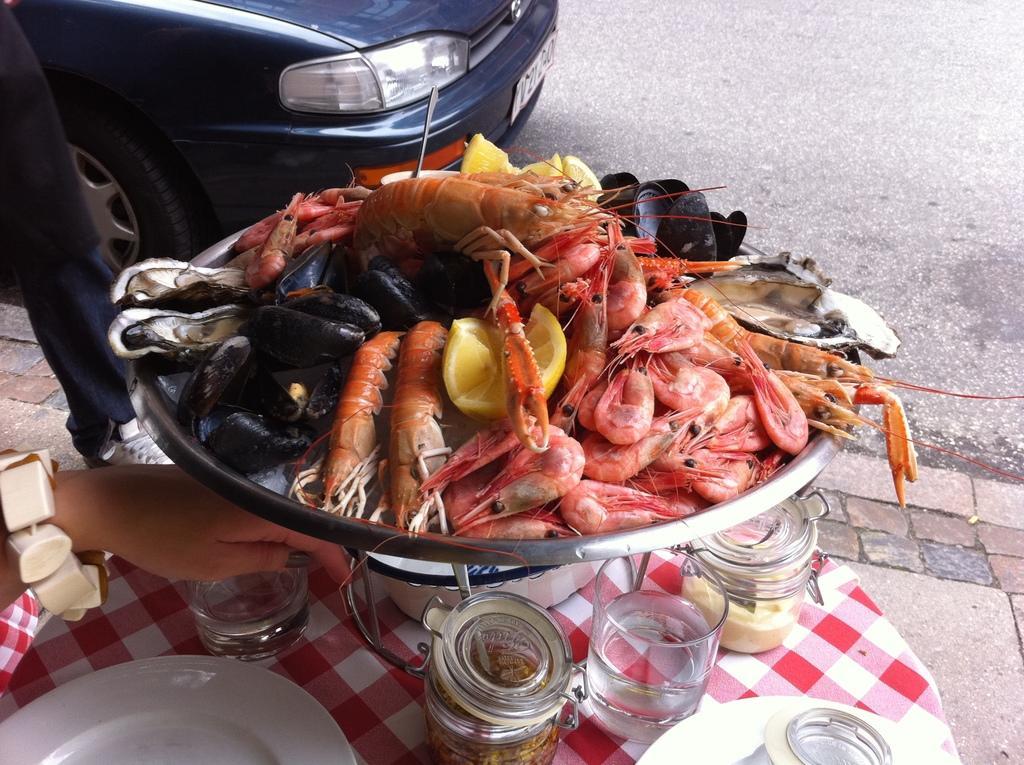Can you describe this image briefly? In the picture we can see a table on it, we can see a cloth on it, we can see some glasses of water and some bottles and beside we can see a bowl of prawns and behind it, we can see a road on it we can see a car is parked which is blue in color. 